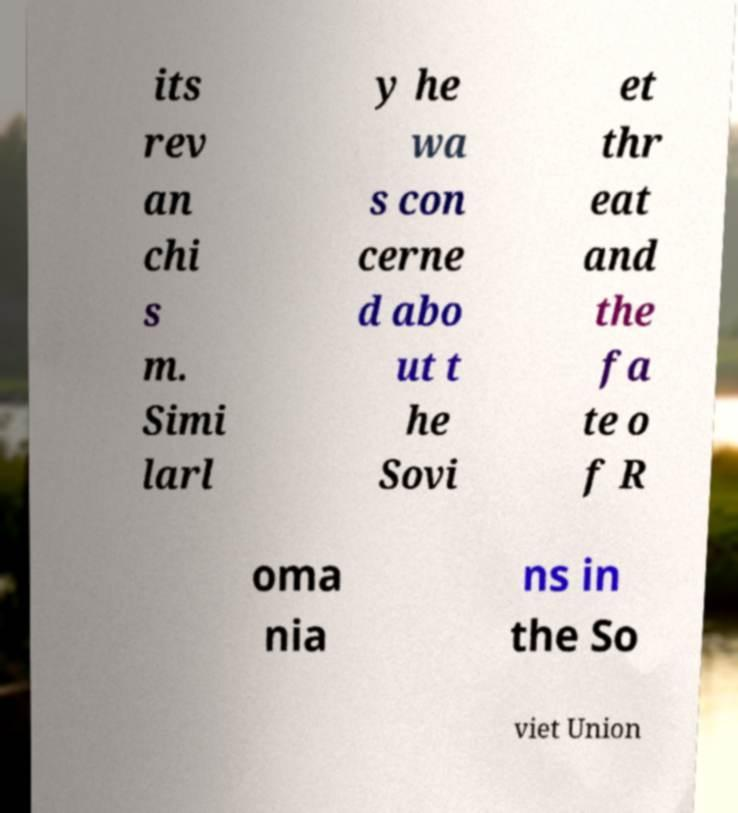Please read and relay the text visible in this image. What does it say? its rev an chi s m. Simi larl y he wa s con cerne d abo ut t he Sovi et thr eat and the fa te o f R oma nia ns in the So viet Union 